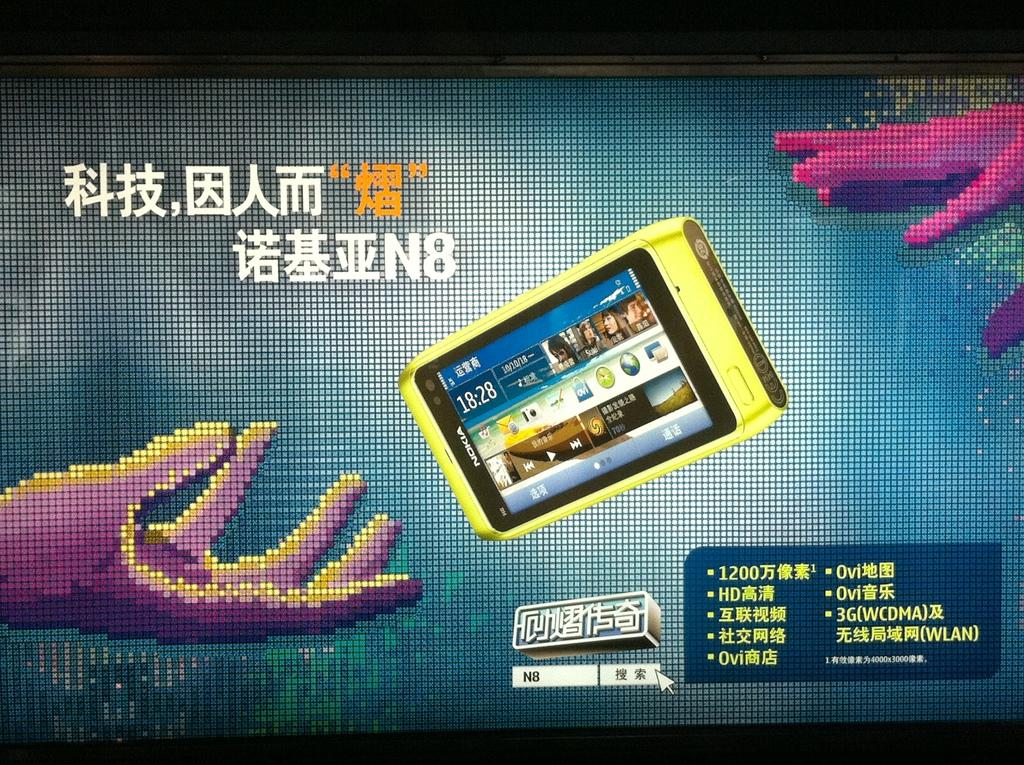<image>
Render a clear and concise summary of the photo. a screen picture that has a nokia phone on it with 18:28 as the time 